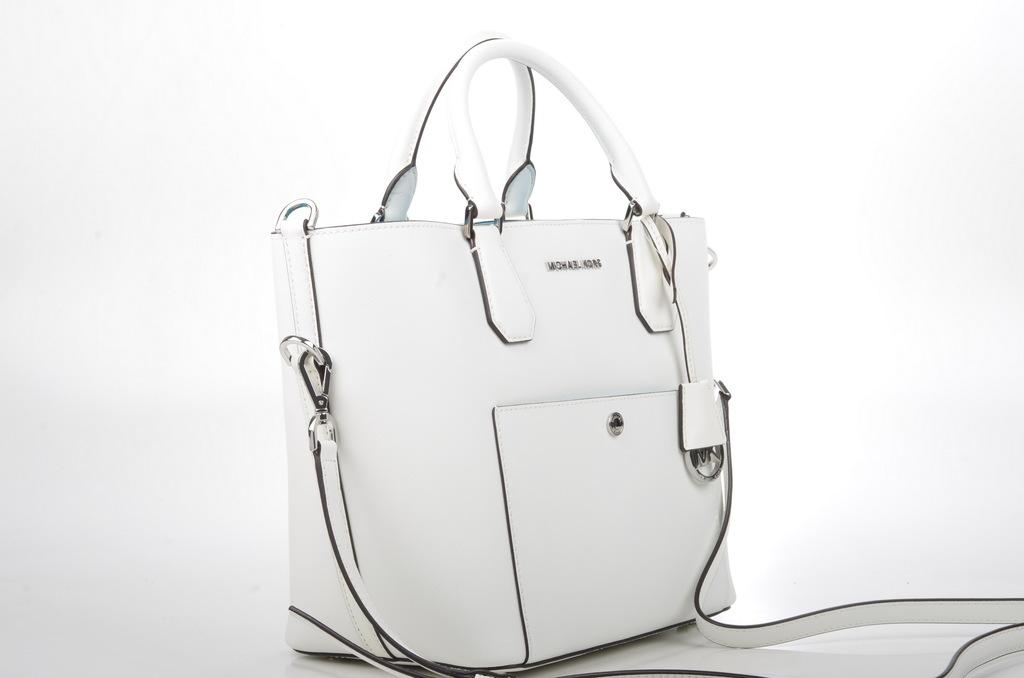What type of accessory is in the image? There is a white handbag in the image. Where is the handbag located? The handbag is on the white floor. What is the dominant color in the background of the image? The background of the image is white. What type of trade is being conducted in the image? There is no indication of any trade being conducted in the image; it features a white handbag on a white floor. What holiday is being celebrated in the image? There is no indication of any holiday being celebrated in the image; it features a white handbag on a white floor. 